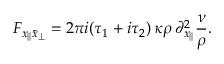Convert formula to latex. <formula><loc_0><loc_0><loc_500><loc_500>F _ { x _ { | | } \bar { x } _ { \perp } } = 2 \pi i ( \tau _ { 1 } + i \tau _ { 2 } ) \, \kappa \rho \, \partial _ { x _ { | | } } ^ { 2 } \frac { \nu } { \rho } .</formula> 